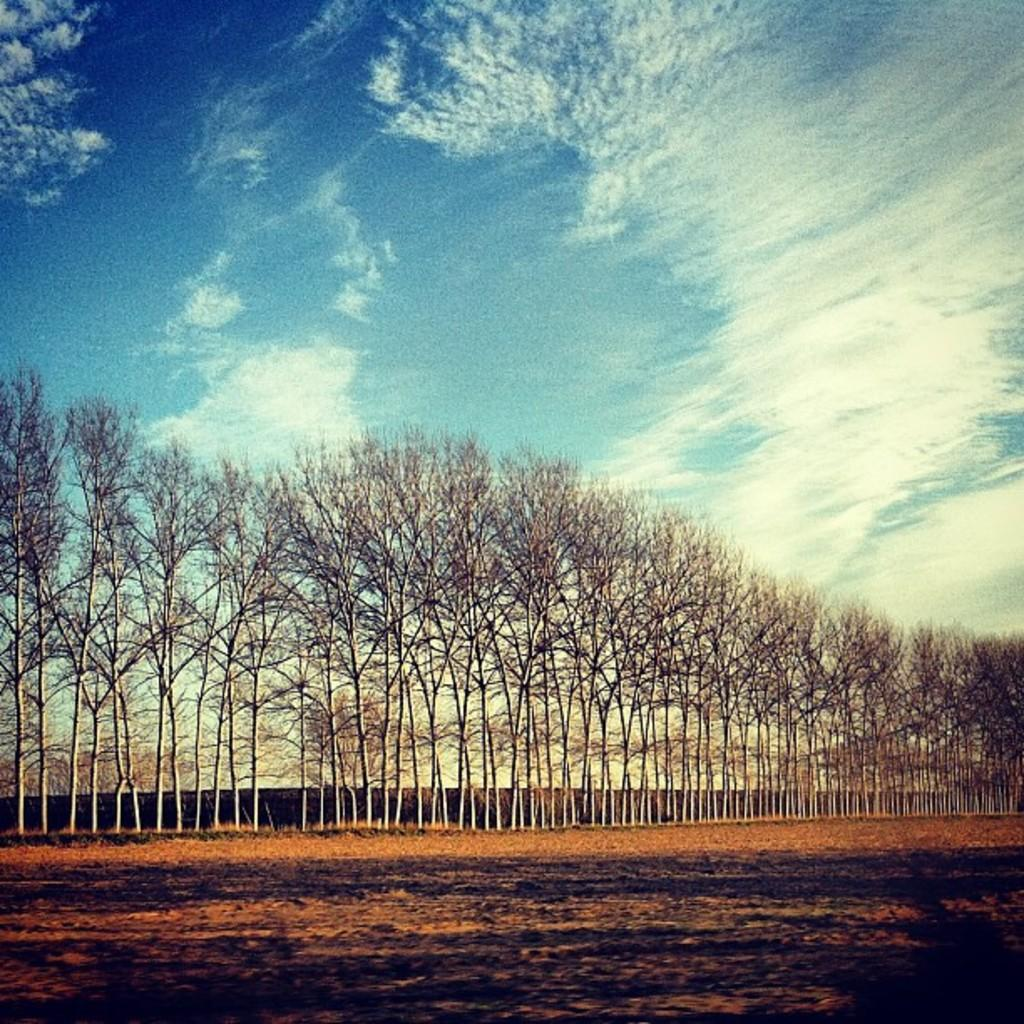What type of vegetation can be seen in the image? There are trees in the image. What is visible in the sky at the top of the image? There are clouds in the sky at the top of the image. What is visible at the bottom of the image? There is ground visible at the bottom of the image. Where is the dock located in the image? There is no dock present in the image. What type of gun can be seen in the image? There is no gun present in the image. 